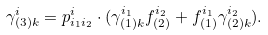<formula> <loc_0><loc_0><loc_500><loc_500>\gamma ^ { i } _ { ( 3 ) k } = p ^ { i } _ { i _ { 1 } i _ { 2 } } \cdot ( \gamma ^ { i _ { 1 } } _ { ( 1 ) k } f ^ { i _ { 2 } } _ { ( 2 ) } + f ^ { i _ { 1 } } _ { ( 1 ) } \gamma ^ { i _ { 2 } } _ { ( 2 ) k } ) .</formula> 